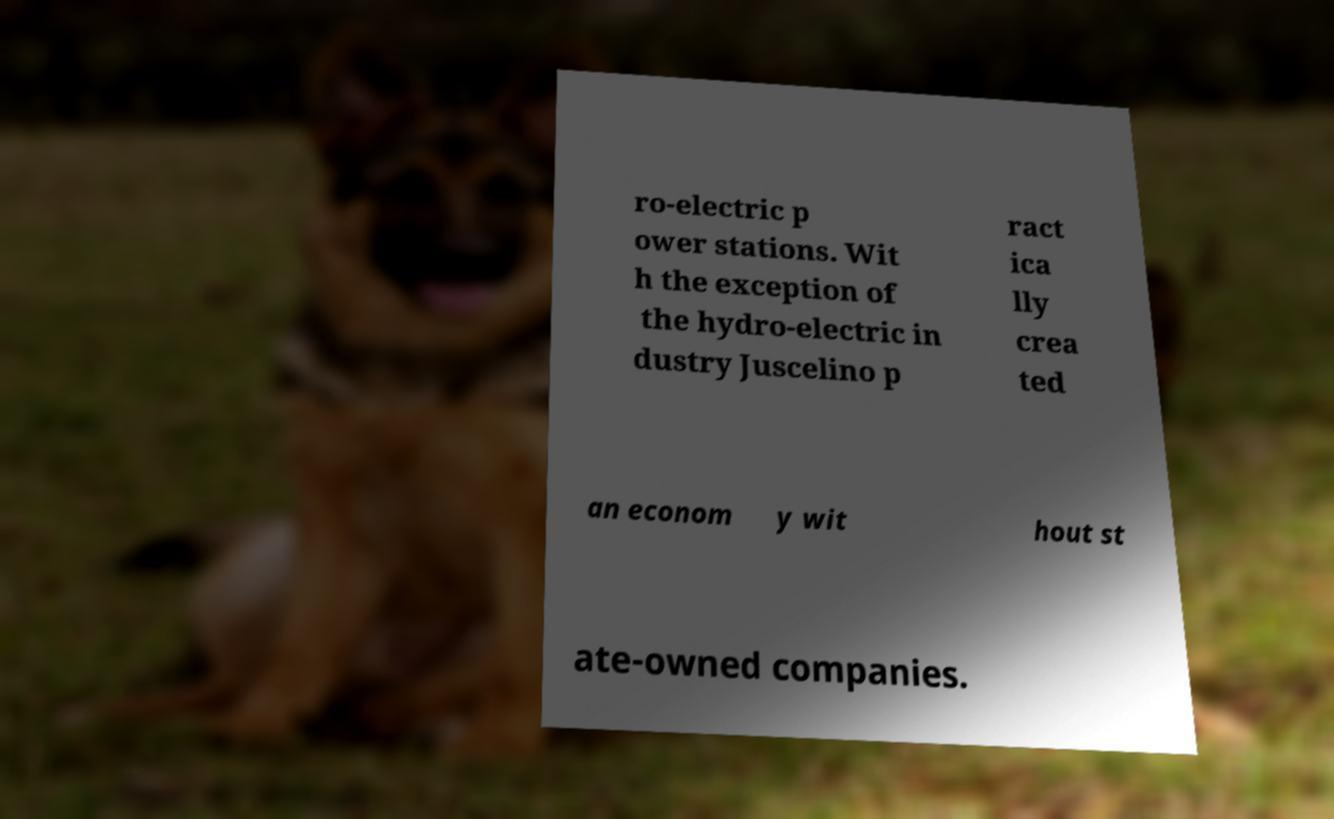Can you read and provide the text displayed in the image?This photo seems to have some interesting text. Can you extract and type it out for me? ro-electric p ower stations. Wit h the exception of the hydro-electric in dustry Juscelino p ract ica lly crea ted an econom y wit hout st ate-owned companies. 